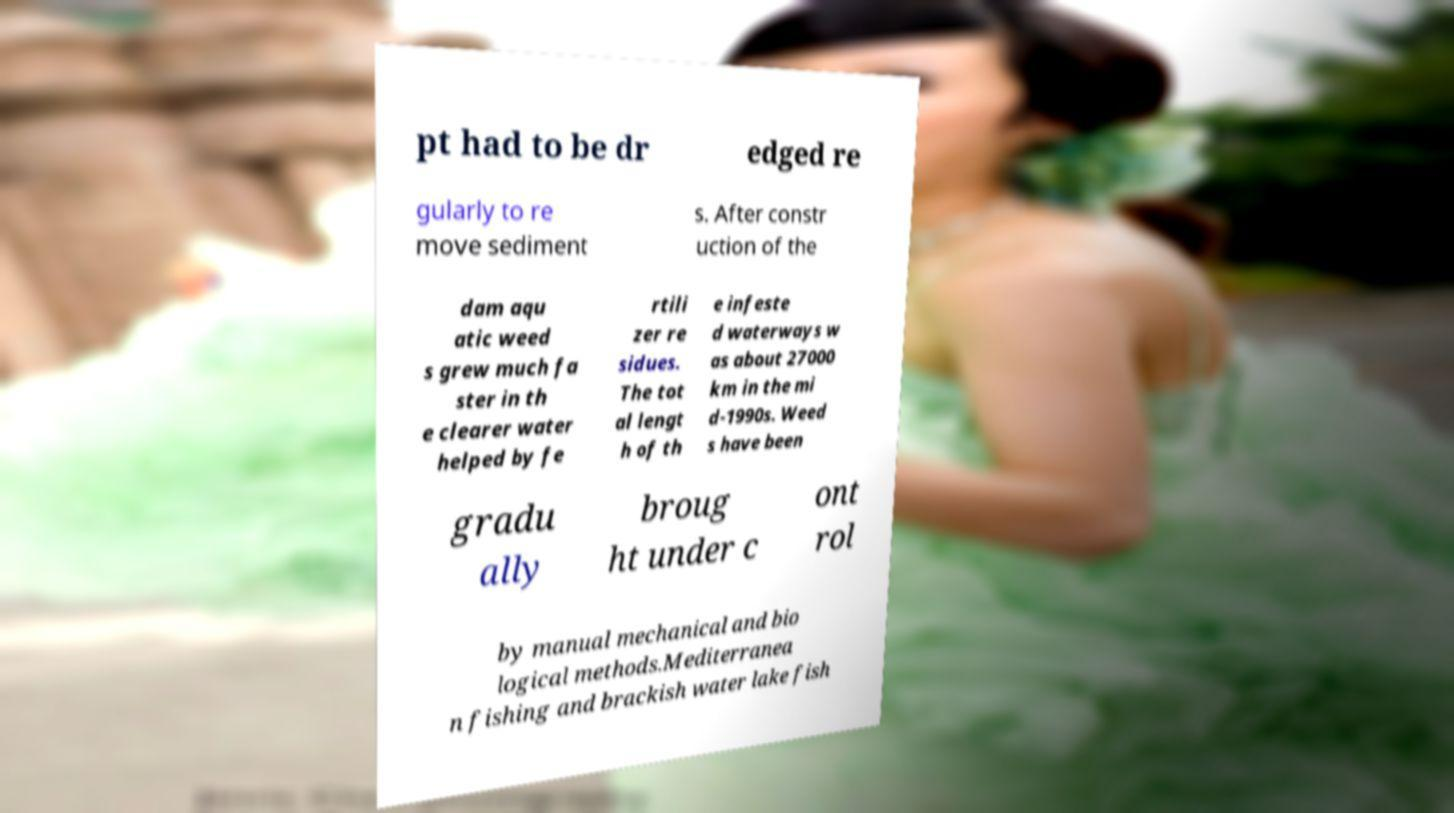Could you assist in decoding the text presented in this image and type it out clearly? pt had to be dr edged re gularly to re move sediment s. After constr uction of the dam aqu atic weed s grew much fa ster in th e clearer water helped by fe rtili zer re sidues. The tot al lengt h of th e infeste d waterways w as about 27000 km in the mi d-1990s. Weed s have been gradu ally broug ht under c ont rol by manual mechanical and bio logical methods.Mediterranea n fishing and brackish water lake fish 